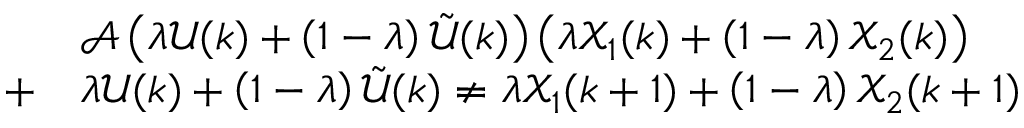Convert formula to latex. <formula><loc_0><loc_0><loc_500><loc_500>\begin{array} { r l } & { \ m a t h s c r { A } \left ( \lambda \ m a t h s c r { U } ( k ) + \left ( 1 - \lambda \right ) \tilde { \ m a t h s c r { U } } ( k ) \right ) \left ( \lambda \ m a t h s c r { X } _ { 1 } ( k ) + \left ( 1 - \lambda \right ) \ m a t h s c r { X } _ { 2 } ( k ) \right ) } \\ { + } & { \lambda \ m a t h s c r { U } ( k ) + \left ( 1 - \lambda \right ) \tilde { \ m a t h s c r { U } } ( k ) \neq \lambda \ m a t h s c r { X } _ { 1 } ( k + 1 ) + \left ( 1 - \lambda \right ) \ m a t h s c r { X } _ { 2 } ( k + 1 ) } \end{array}</formula> 